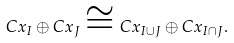Convert formula to latex. <formula><loc_0><loc_0><loc_500><loc_500>C x _ { I } \oplus C x _ { J } \cong C x _ { I \cup J } \oplus C x _ { I \cap J } .</formula> 